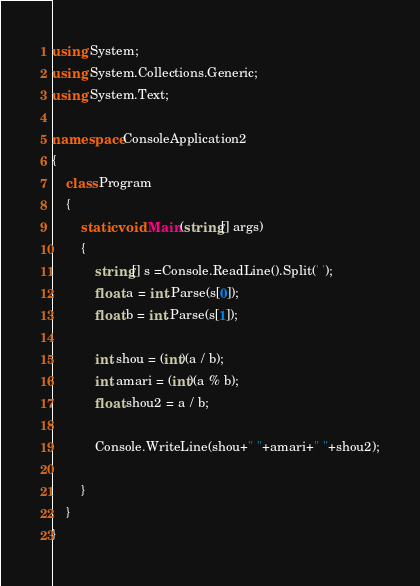<code> <loc_0><loc_0><loc_500><loc_500><_C#_>using System;
using System.Collections.Generic;
using System.Text;

namespace ConsoleApplication2
{
    class Program
    {
        static void Main(string[] args)
        {
            string[] s =Console.ReadLine().Split(' ');
            float a = int.Parse(s[0]);
            float b = int.Parse(s[1]);

            int shou = (int)(a / b);
            int amari = (int)(a % b);
            float shou2 = a / b;

            Console.WriteLine(shou+" "+amari+" "+shou2);

        }
    }
}</code> 